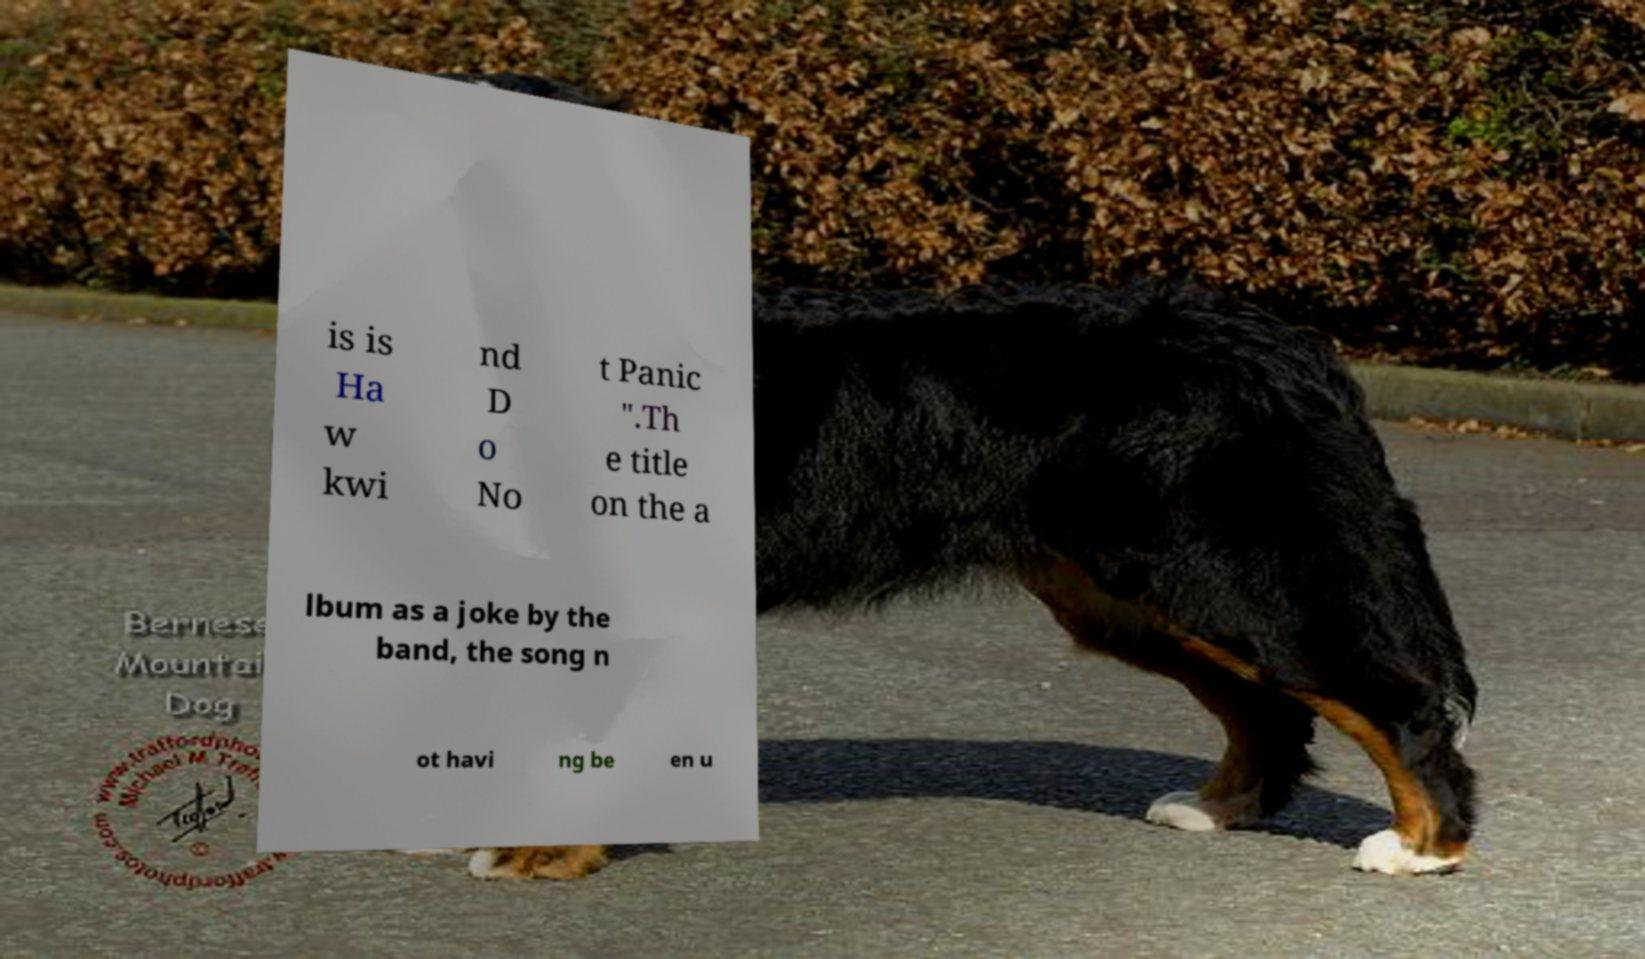Can you accurately transcribe the text from the provided image for me? is is Ha w kwi nd D o No t Panic ".Th e title on the a lbum as a joke by the band, the song n ot havi ng be en u 